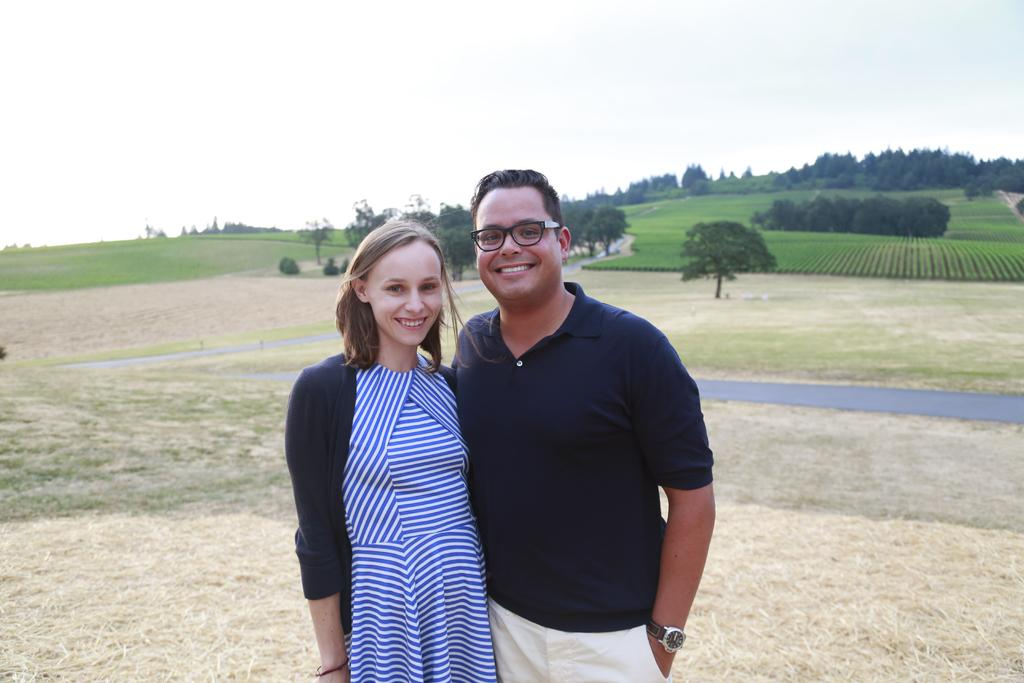How many people are present in the image? There are two people standing in the image. What can be seen behind the people? There are trees visible behind the people. What else is visible in the background? There are fields and the sky visible in the background. What type of approval is the squirrel seeking from the people in the image? There is no squirrel present in the image, so it is not possible to determine if any approval is being sought. 